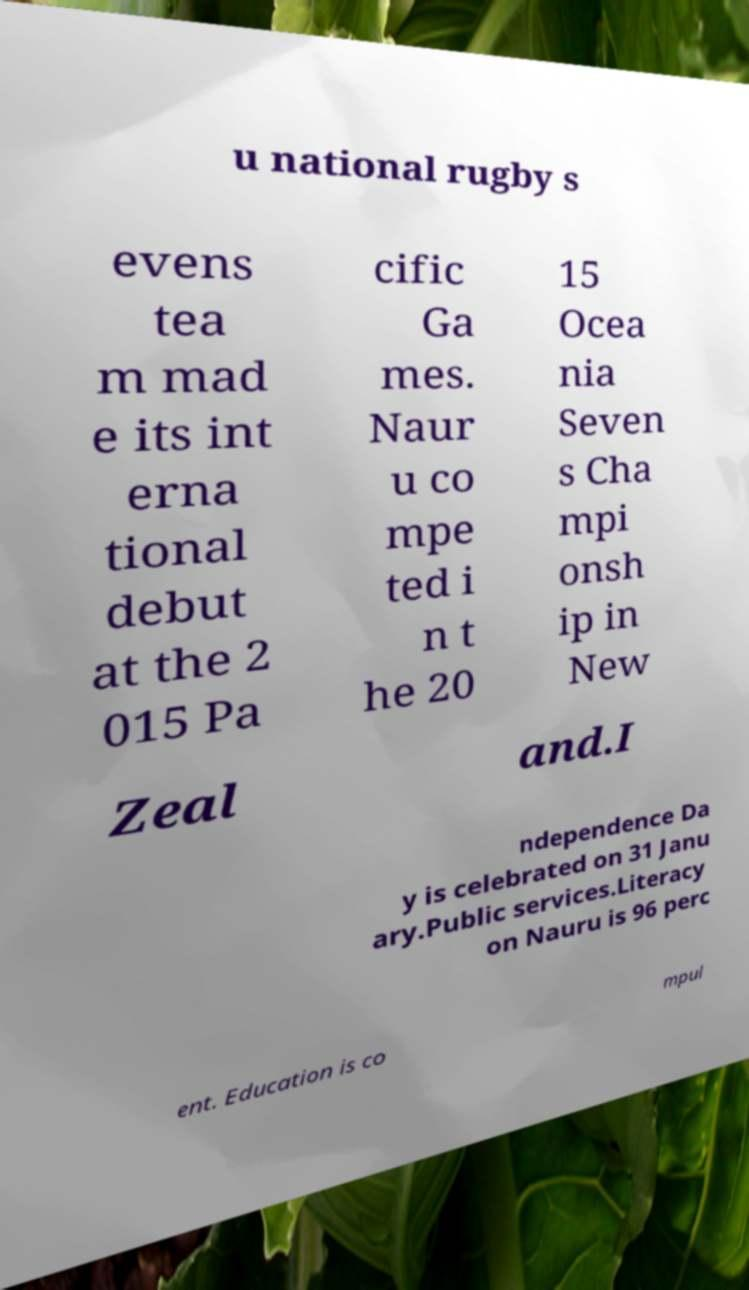I need the written content from this picture converted into text. Can you do that? u national rugby s evens tea m mad e its int erna tional debut at the 2 015 Pa cific Ga mes. Naur u co mpe ted i n t he 20 15 Ocea nia Seven s Cha mpi onsh ip in New Zeal and.I ndependence Da y is celebrated on 31 Janu ary.Public services.Literacy on Nauru is 96 perc ent. Education is co mpul 